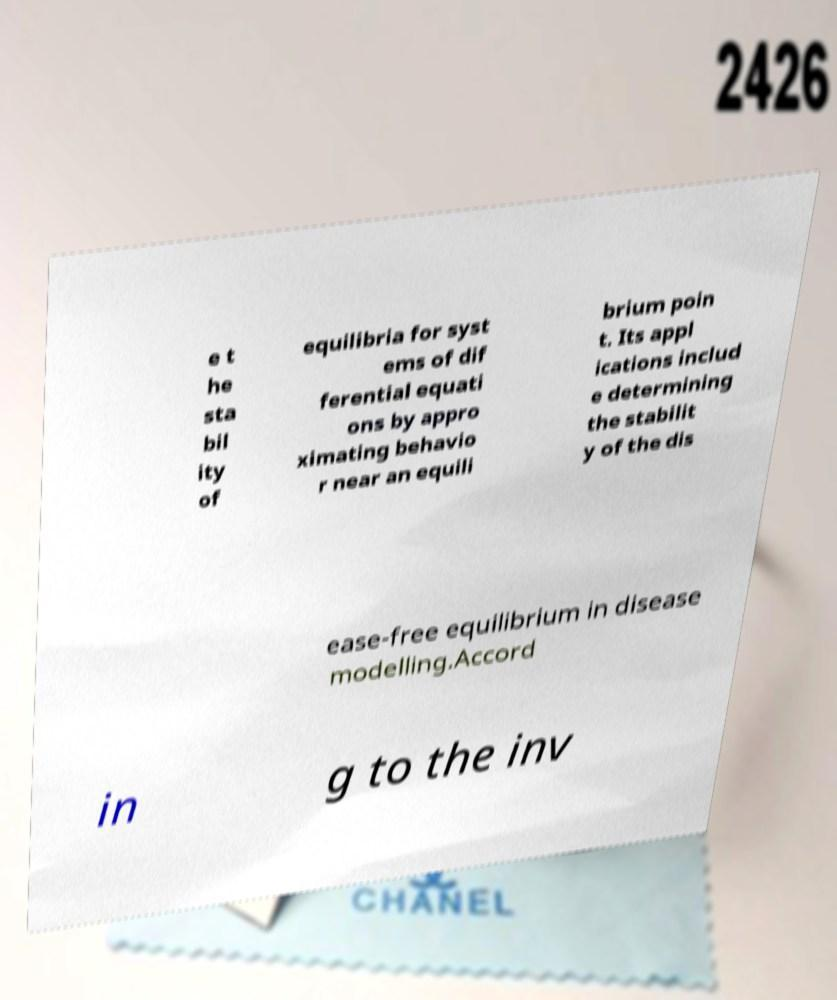Could you assist in decoding the text presented in this image and type it out clearly? e t he sta bil ity of equilibria for syst ems of dif ferential equati ons by appro ximating behavio r near an equili brium poin t. Its appl ications includ e determining the stabilit y of the dis ease-free equilibrium in disease modelling.Accord in g to the inv 